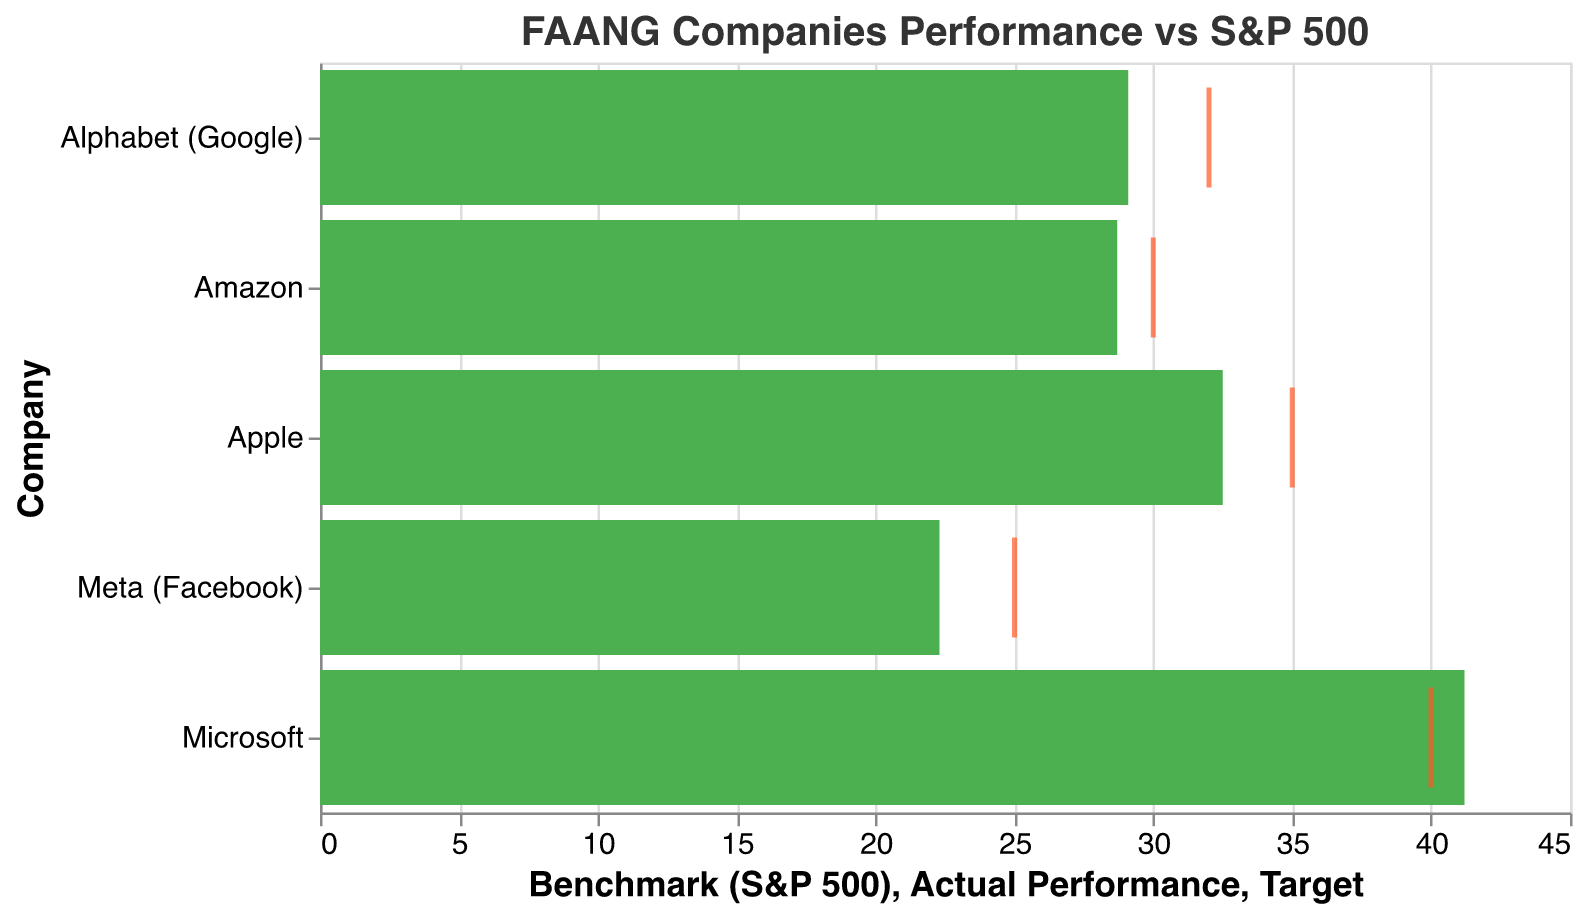What does the title of the chart indicate? The title "FAANG Companies Performance vs S&P 500" suggests that the chart is comparing the performance of FAANG companies against the S&P 500 benchmark.
Answer: It indicates a comparison between FAANG companies' performances and the S&P 500 benchmark How many companies are being compared in the chart? The chart lists the FAANG companies, which according to the data provided, includes Apple, Amazon, Microsoft, Alphabet (Google), and Meta (Facebook).
Answer: Five companies Which company has the highest actual performance in the chart? By looking at the length of the green bars, Microsoft has the highest actual performance at 41.2%.
Answer: Microsoft What is the benchmark value of the S&P 500? The benchmark value for the S&P 500 is shown as a grey bar, and it is consistent at 15.8 for all companies.
Answer: 15.8 How does Apple's actual performance compare to its target performance? Apple's actual performance bar (green) reaches 32.5, whereas its target performance (red tick) is at 35. This indicates that Apple's performance is below its target.
Answer: Below its target Which company came closest to their performance target? By comparing the positions of the red ticks (targets) and green bars (actual performances), Microsoft, with a target of 40 and an actual performance of 41.2, is the closest to its target.
Answer: Microsoft What is the difference between Meta's actual performance and its target? Meta has an actual performance of 22.3 and a target of 25. The difference is calculated as 25 - 22.3.
Answer: 2.7 Which companies outperformed the S&P 500 benchmark? All companies' actual performance bars (green) are longer than the benchmark bar (grey) at 15.8. Thus, Apple, Amazon, Microsoft, Alphabet (Google), and Meta (Facebook) have all outperformed the S&P 500 benchmark.
Answer: All listed companies Which company has the lowest actual performance and how does it compare to the S&P 500? Meta's actual performance is the lowest at 22.3%. However, this is still higher than the S&P 500 benchmark of 15.8%.
Answer: Meta's actual performance is higher than the S&P 500 What is the average actual performance of FAANG companies? To find the average actual performance, sum the actual performances: 32.5 + 28.7 + 41.2 + 29.1 + 22.3 = 153.8. Then, divide by the number of companies, which is 5. 153.8 / 5 = 30.76.
Answer: 30.76 